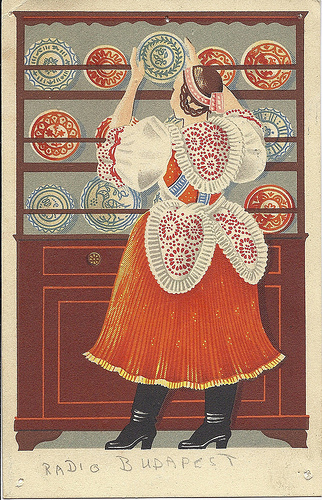<image>
Is the dish on the woman? No. The dish is not positioned on the woman. They may be near each other, but the dish is not supported by or resting on top of the woman. 